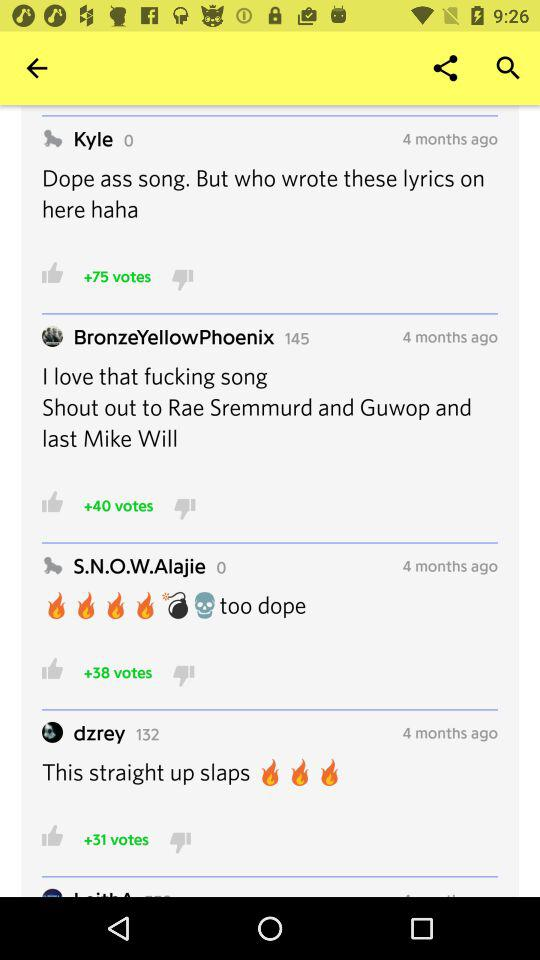What number is present ahead of the "BronzeYellowPhoenix" user? The number is 145. 